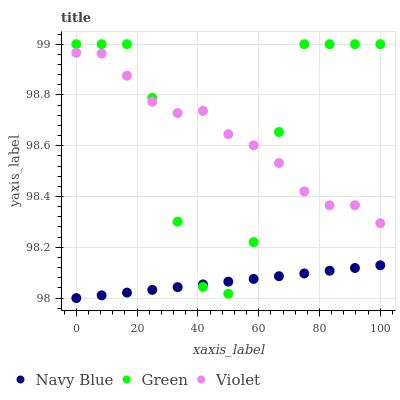Does Navy Blue have the minimum area under the curve?
Answer yes or no. Yes. Does Green have the maximum area under the curve?
Answer yes or no. Yes. Does Violet have the minimum area under the curve?
Answer yes or no. No. Does Violet have the maximum area under the curve?
Answer yes or no. No. Is Navy Blue the smoothest?
Answer yes or no. Yes. Is Green the roughest?
Answer yes or no. Yes. Is Violet the smoothest?
Answer yes or no. No. Is Violet the roughest?
Answer yes or no. No. Does Navy Blue have the lowest value?
Answer yes or no. Yes. Does Green have the lowest value?
Answer yes or no. No. Does Green have the highest value?
Answer yes or no. Yes. Does Violet have the highest value?
Answer yes or no. No. Is Navy Blue less than Violet?
Answer yes or no. Yes. Is Violet greater than Navy Blue?
Answer yes or no. Yes. Does Green intersect Violet?
Answer yes or no. Yes. Is Green less than Violet?
Answer yes or no. No. Is Green greater than Violet?
Answer yes or no. No. Does Navy Blue intersect Violet?
Answer yes or no. No. 